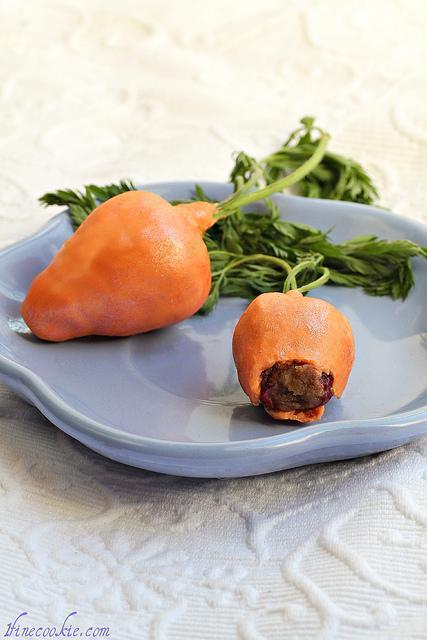How many buses are on the street?
Give a very brief answer. 0. 